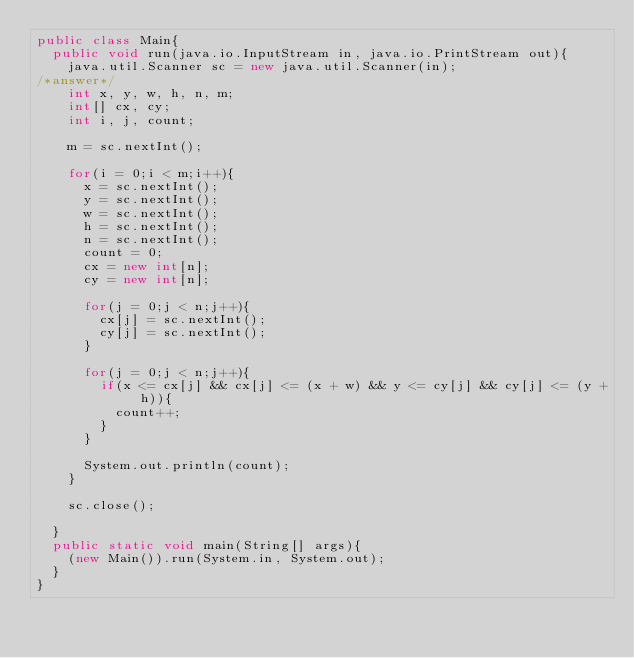Convert code to text. <code><loc_0><loc_0><loc_500><loc_500><_Java_>public class Main{
  public void run(java.io.InputStream in, java.io.PrintStream out){
    java.util.Scanner sc = new java.util.Scanner(in);
/*answer*/
    int x, y, w, h, n, m;
    int[] cx, cy;
    int i, j, count;

    m = sc.nextInt();

    for(i = 0;i < m;i++){
      x = sc.nextInt();
      y = sc.nextInt();
      w = sc.nextInt();
      h = sc.nextInt();
      n = sc.nextInt();
      count = 0;
      cx = new int[n];
      cy = new int[n];      

      for(j = 0;j < n;j++){
        cx[j] = sc.nextInt();
        cy[j] = sc.nextInt();
      }

      for(j = 0;j < n;j++){
        if(x <= cx[j] && cx[j] <= (x + w) && y <= cy[j] && cy[j] <= (y + h)){
          count++;
        }
      }

      System.out.println(count);
    }

    sc.close();

  }
  public static void main(String[] args){
    (new Main()).run(System.in, System.out);
  }
}</code> 